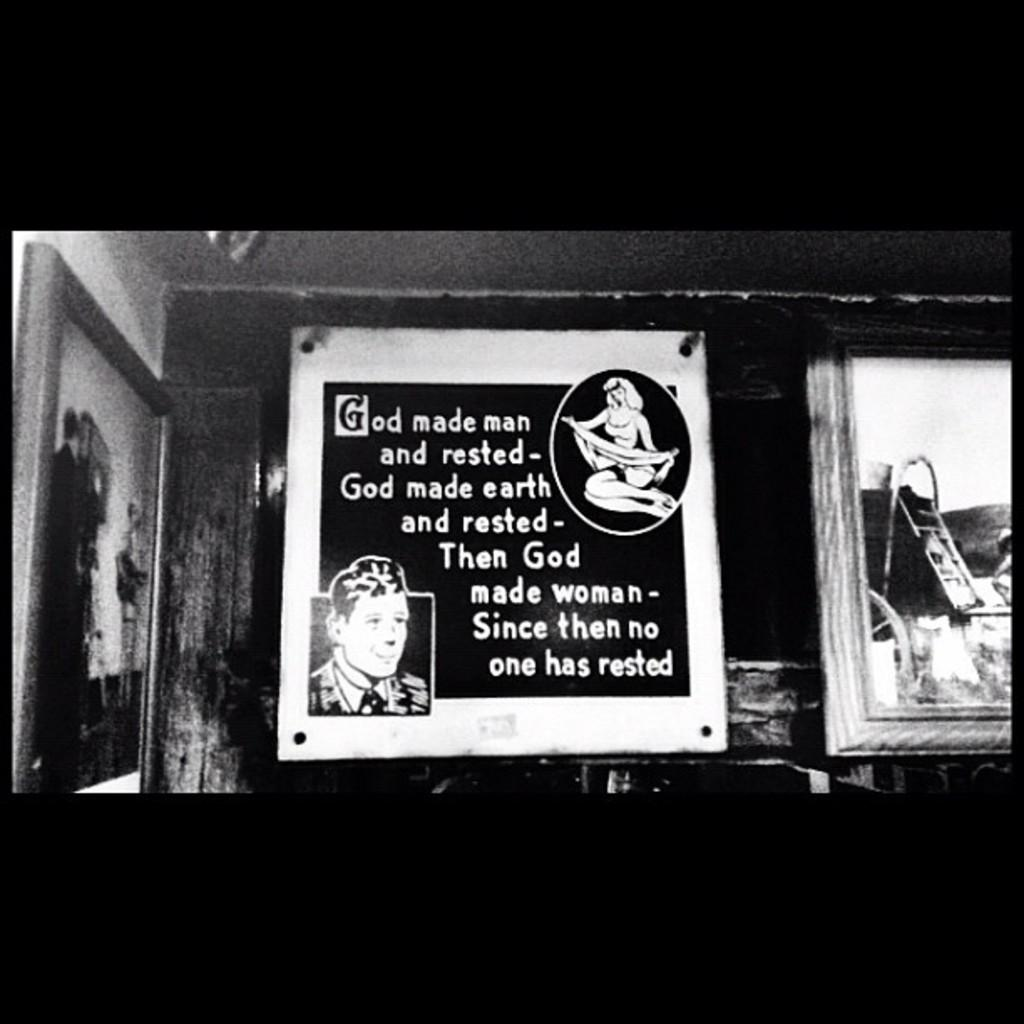<image>
Share a concise interpretation of the image provided. A poster reading god made man and rested God made Earth. 